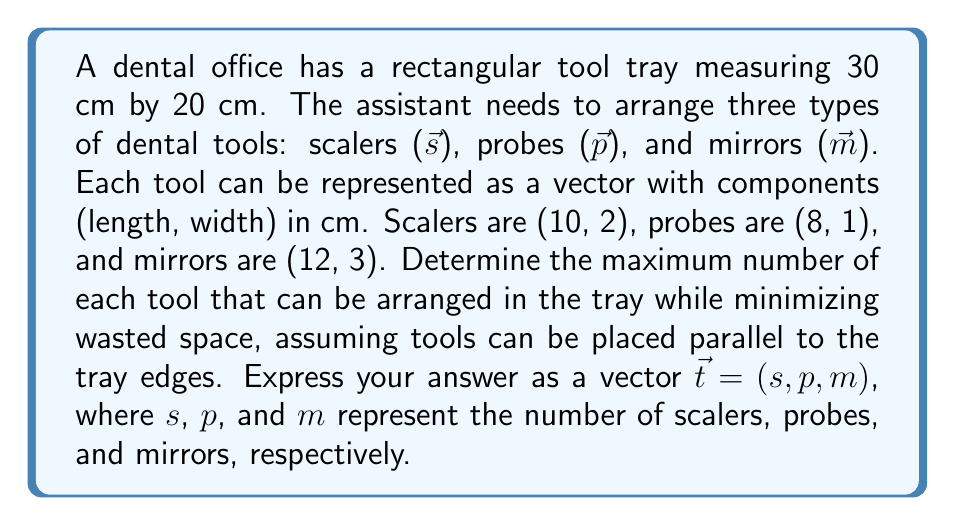Can you solve this math problem? Let's approach this problem step-by-step using vector analysis:

1) First, we need to consider the area of the tray:
   $A_{tray} = 30 \text{ cm} \times 20 \text{ cm} = 600 \text{ cm}^2$

2) Now, let's represent each tool as an area vector:
   $\vec{s} = (10, 2) \implies A_s = 20 \text{ cm}^2$
   $\vec{p} = (8, 1) \implies A_p = 8 \text{ cm}^2$
   $\vec{m} = (12, 3) \implies A_m = 36 \text{ cm}^2$

3) We can express the problem as a linear combination:
   $s\vec{s} + p\vec{p} + m\vec{m} \leq (30, 20)$

4) This gives us two inequalities:
   $10s + 8p + 12m \leq 30$
   $2s + p + 3m \leq 20$

5) We want to maximize the number of tools while minimizing waste. This can be expressed as maximizing:
   $f(s,p,m) = s + p + m$
   
   Subject to the constraints:
   $10s + 8p + 12m \leq 30$
   $2s + p + 3m \leq 20$
   $s, p, m \geq 0$ and integer

6) This is an integer linear programming problem. We can solve it by trying different integer combinations that satisfy the constraints.

7) After trying various combinations, we find that the optimal solution is:
   $s = 1, p = 2, m = 1$

8) This arrangement uses:
   $(1 \times 10 + 2 \times 8 + 1 \times 12) = 38 \text{ cm}$ in length
   $(1 \times 2 + 2 \times 1 + 1 \times 3) = 7 \text{ cm}$ in width

9) The total area used is:
   $1 \times 20 + 2 \times 8 + 1 \times 36 = 72 \text{ cm}^2$

10) This leaves a wasted space of:
    $600 - 72 = 528 \text{ cm}^2$

Therefore, the most efficient arrangement is represented by the vector $\vec{t} = (1, 2, 1)$.
Answer: $\vec{t} = (1, 2, 1)$ 